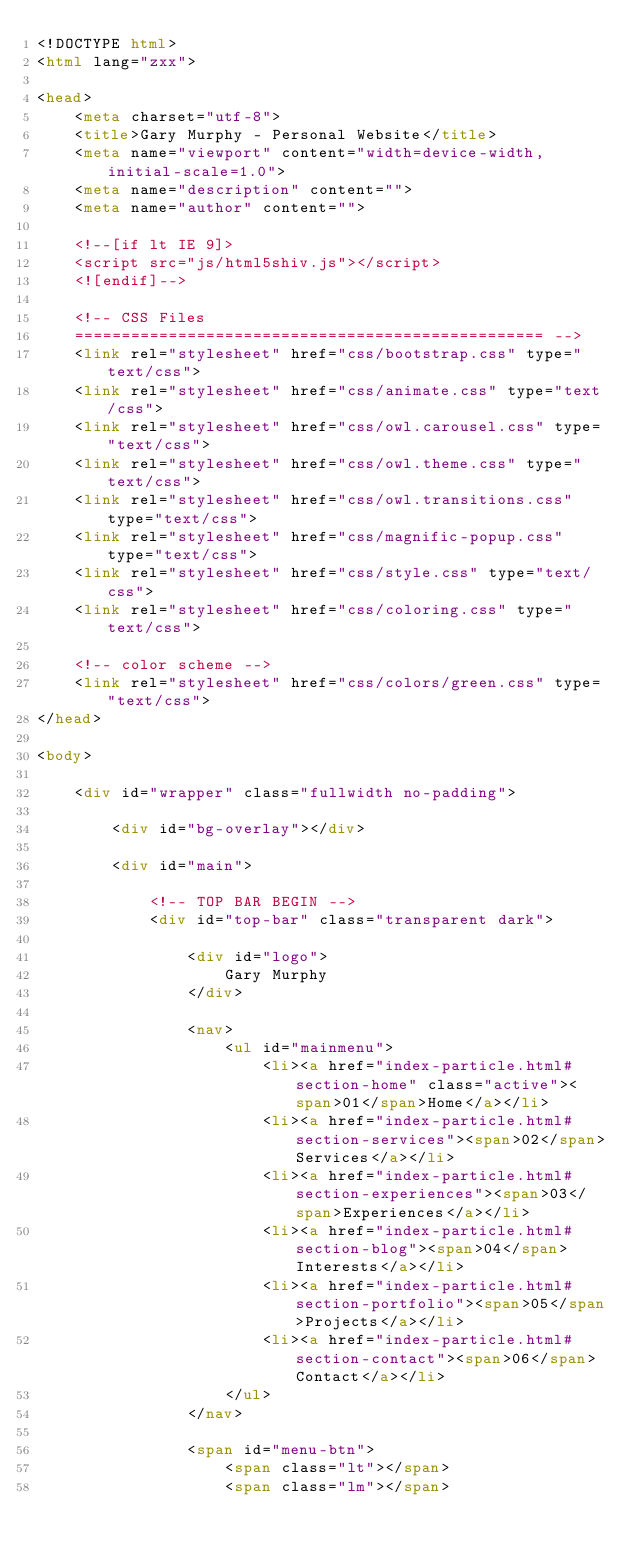<code> <loc_0><loc_0><loc_500><loc_500><_HTML_><!DOCTYPE html>
<html lang="zxx">

<head>
    <meta charset="utf-8">
    <title>Gary Murphy - Personal Website</title>
    <meta name="viewport" content="width=device-width, initial-scale=1.0">
    <meta name="description" content="">
    <meta name="author" content="">

    <!--[if lt IE 9]>
	<script src="js/html5shiv.js"></script>
	<![endif]-->

    <!-- CSS Files
    ================================================== -->
    <link rel="stylesheet" href="css/bootstrap.css" type="text/css">
    <link rel="stylesheet" href="css/animate.css" type="text/css">
    <link rel="stylesheet" href="css/owl.carousel.css" type="text/css">
    <link rel="stylesheet" href="css/owl.theme.css" type="text/css">
    <link rel="stylesheet" href="css/owl.transitions.css" type="text/css">
    <link rel="stylesheet" href="css/magnific-popup.css" type="text/css">
    <link rel="stylesheet" href="css/style.css" type="text/css">
	<link rel="stylesheet" href="css/coloring.css" type="text/css">

    <!-- color scheme -->
    <link rel="stylesheet" href="css/colors/green.css" type="text/css">
</head>

<body>

    <div id="wrapper" class="fullwidth no-padding">
	
		<div id="bg-overlay"></div>
		
        <div id="main">

            <!-- TOP BAR BEGIN -->
            <div id="top-bar" class="transparent dark">

                <div id="logo">
                    Gary Murphy
                </div>

                <nav>
                    <ul id="mainmenu">
                        <li><a href="index-particle.html#section-home" class="active"><span>01</span>Home</a></li>
                        <li><a href="index-particle.html#section-services"><span>02</span>Services</a></li>
                        <li><a href="index-particle.html#section-experiences"><span>03</span>Experiences</a></li>
                        <li><a href="index-particle.html#section-blog"><span>04</span>Interests</a></li>
                        <li><a href="index-particle.html#section-portfolio"><span>05</span>Projects</a></li>
                        <li><a href="index-particle.html#section-contact"><span>06</span>Contact</a></li>
                    </ul>
                </nav>

                <span id="menu-btn">
					<span class="lt"></span>
					<span class="lm"></span></code> 